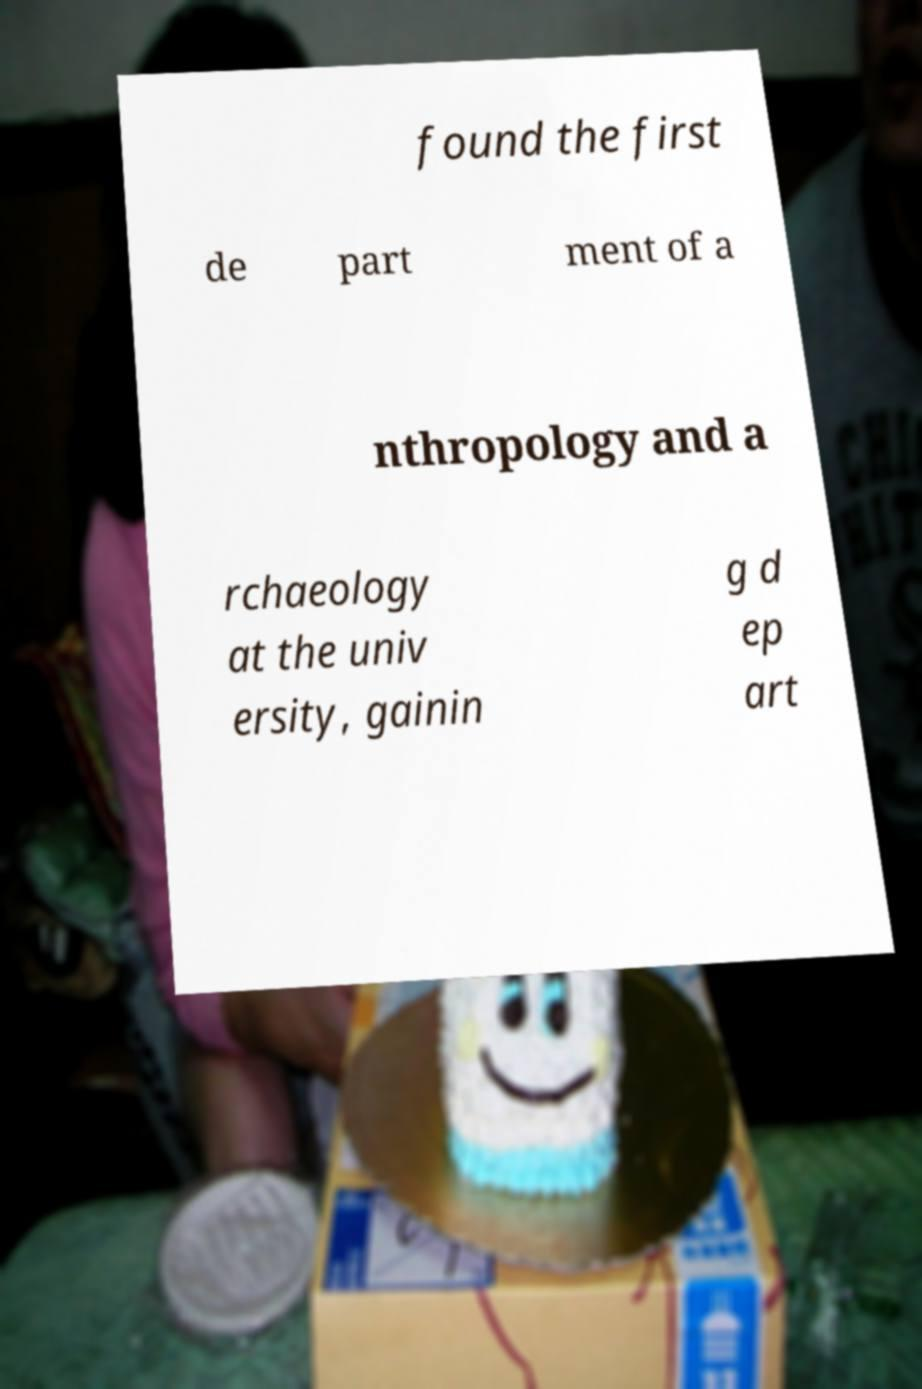Can you read and provide the text displayed in the image?This photo seems to have some interesting text. Can you extract and type it out for me? found the first de part ment of a nthropology and a rchaeology at the univ ersity, gainin g d ep art 